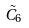Convert formula to latex. <formula><loc_0><loc_0><loc_500><loc_500>\tilde { C } _ { 6 }</formula> 